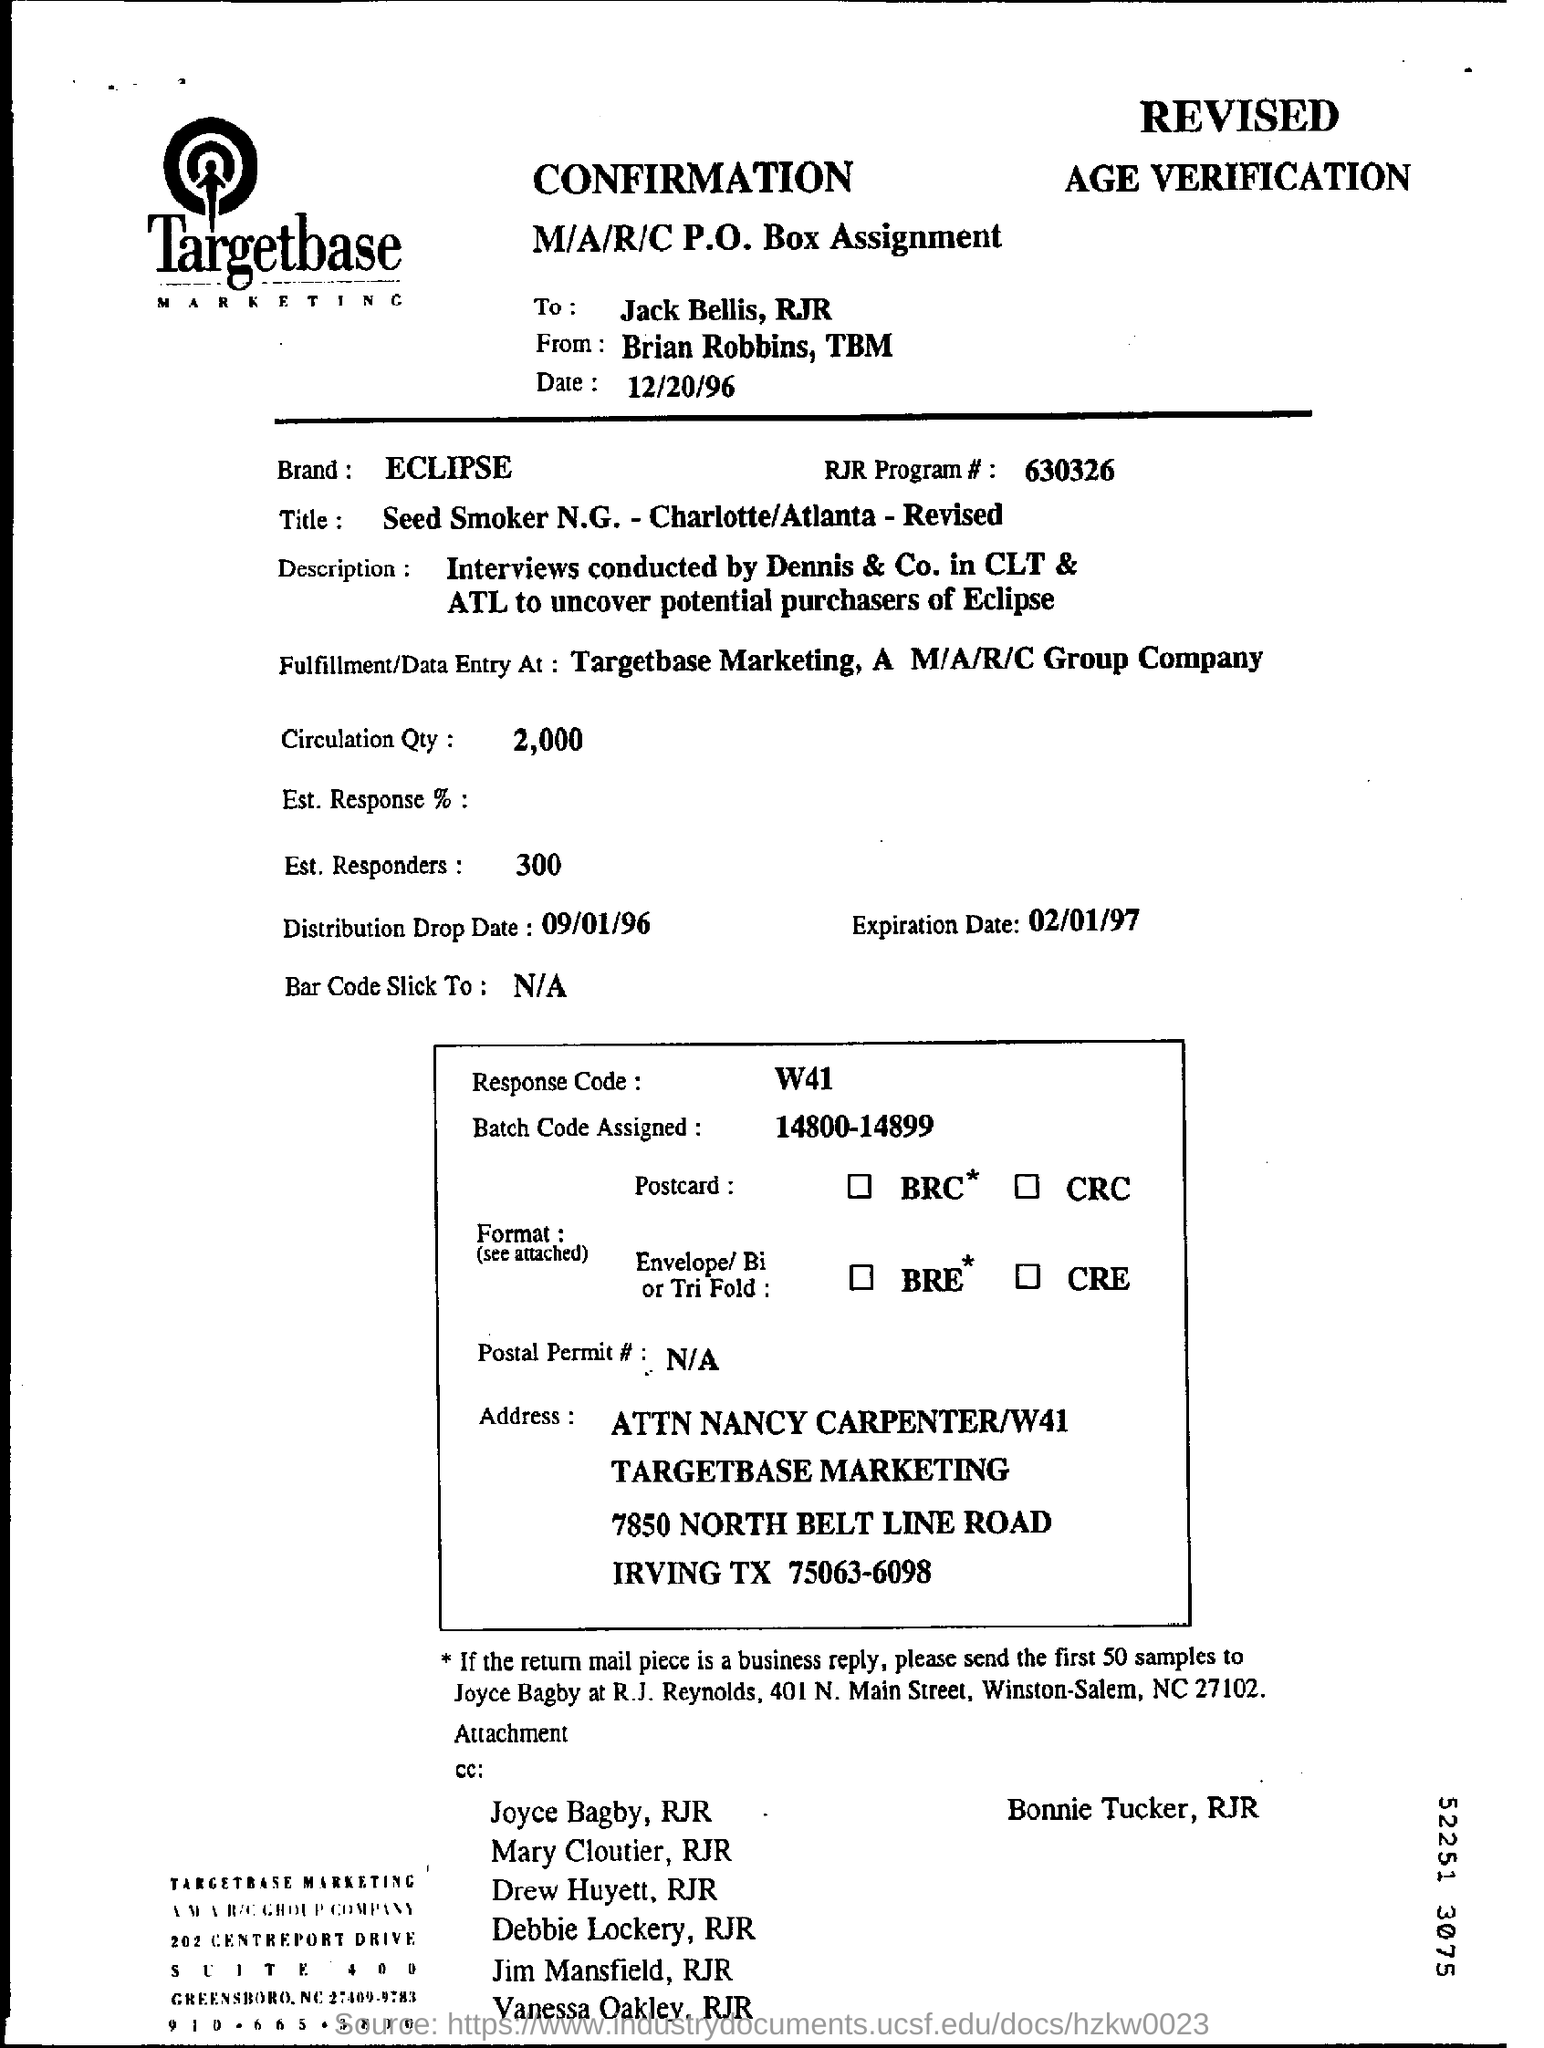Specify some key components in this picture. The sender of this message is Brian Robbins. The date mentioned is December 20, 1996. This message is intended for Jack Bells, RJR. The brand mentioned is Eclipse. 